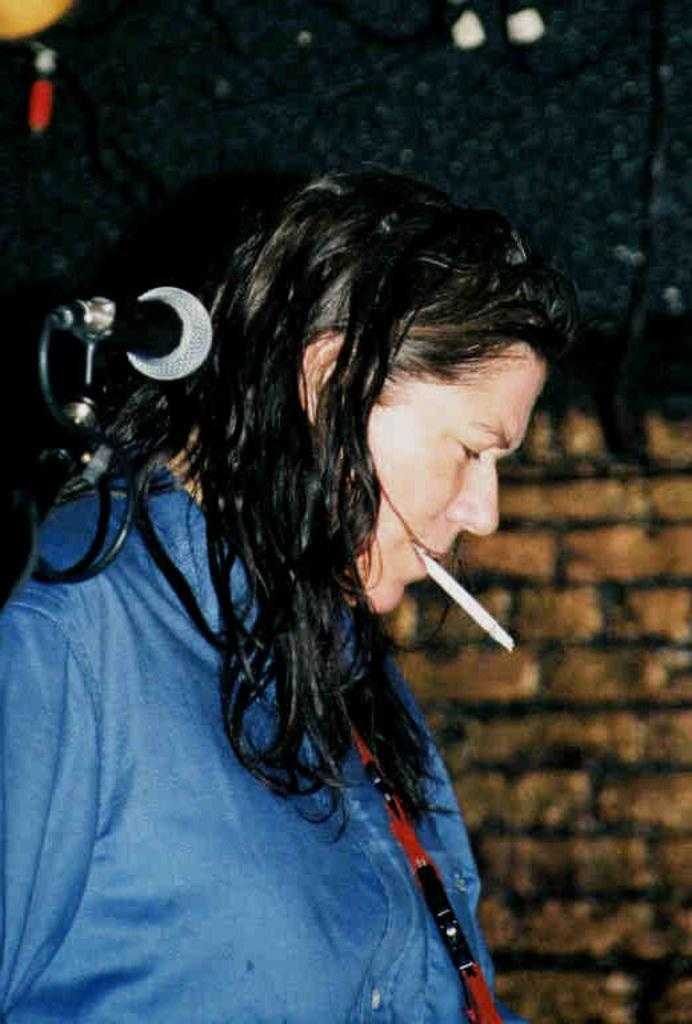What is present in the image? There is a person in the image. What can be observed about the person's attire? The person is wearing clothes. What is the person doing with their mouth? The person is holding an object in their mouth. What is the object that the person is holding? The object appears to be a microphone. Can you describe any additional details about the image? There is a cable wire visible in the image, and the background is slightly blurred. Where are the dolls playing in the image? There are no dolls present in the image. What type of thrill can be experienced by the person in the image? The image does not provide information about any thrilling experiences; it only shows a person holding a microphone. 